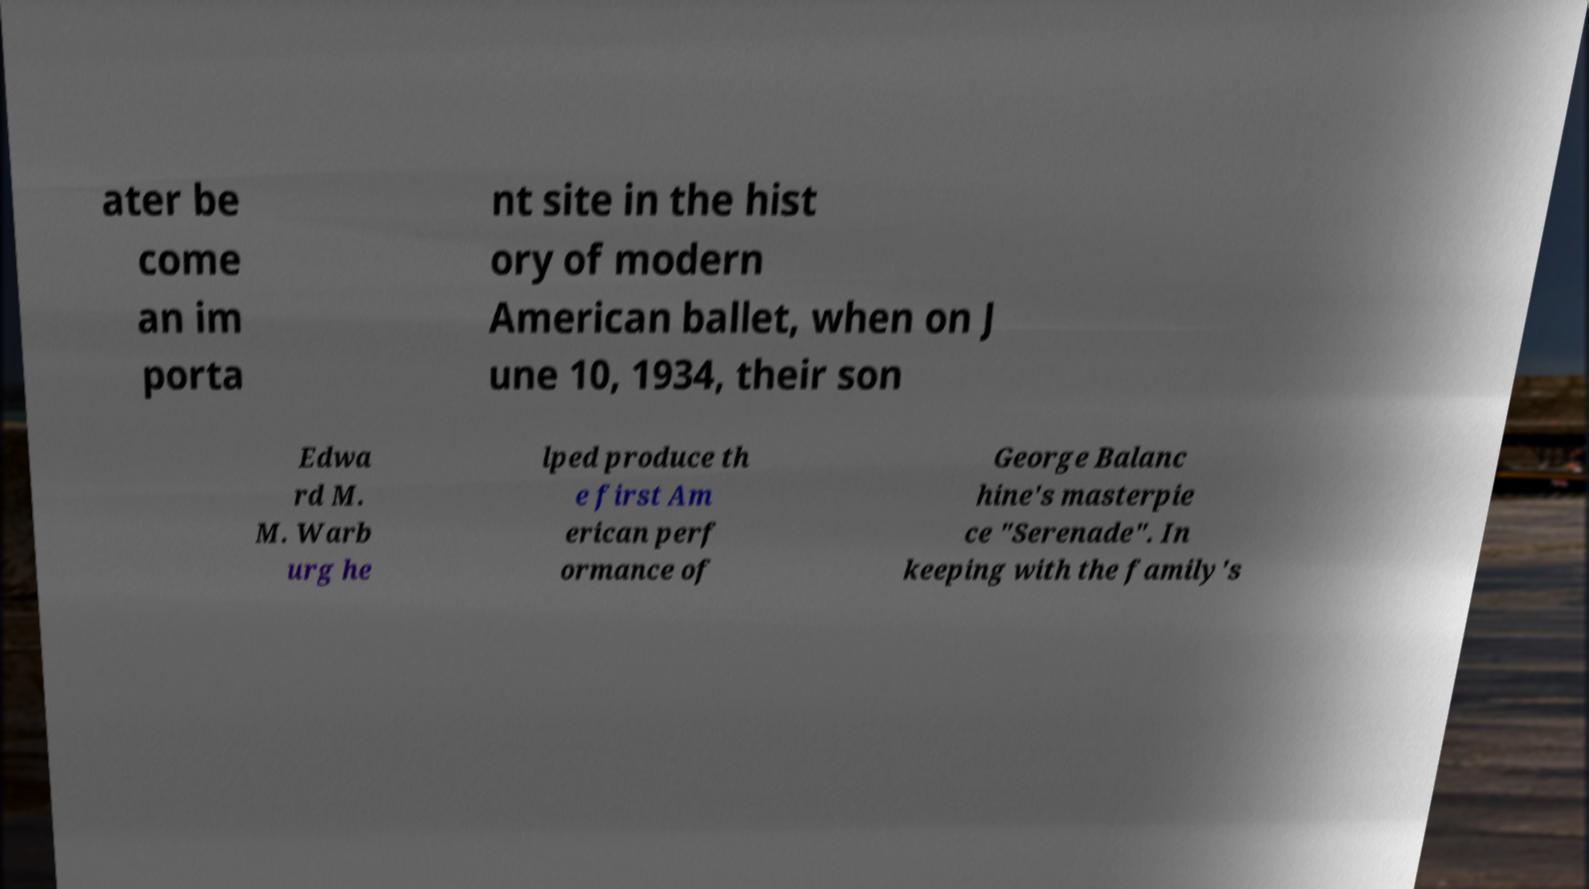Can you accurately transcribe the text from the provided image for me? ater be come an im porta nt site in the hist ory of modern American ballet, when on J une 10, 1934, their son Edwa rd M. M. Warb urg he lped produce th e first Am erican perf ormance of George Balanc hine's masterpie ce "Serenade". In keeping with the family's 